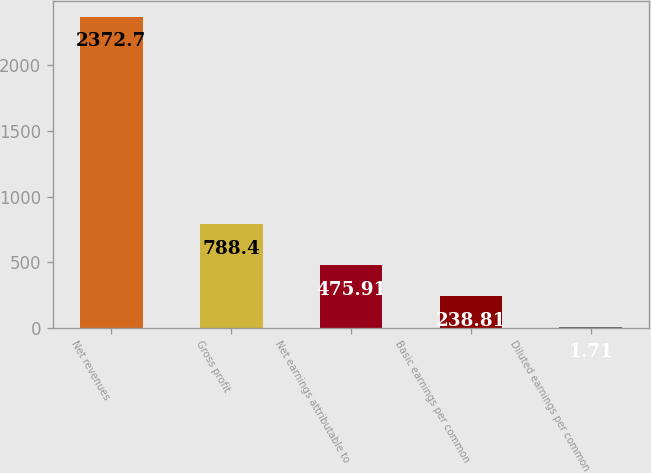<chart> <loc_0><loc_0><loc_500><loc_500><bar_chart><fcel>Net revenues<fcel>Gross profit<fcel>Net earnings attributable to<fcel>Basic earnings per common<fcel>Diluted earnings per common<nl><fcel>2372.7<fcel>788.4<fcel>475.91<fcel>238.81<fcel>1.71<nl></chart> 